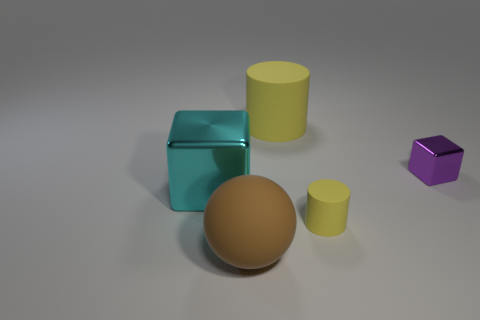Add 4 large yellow matte cylinders. How many objects exist? 9 Subtract all cylinders. How many objects are left? 3 Add 2 blue objects. How many blue objects exist? 2 Subtract 0 cyan cylinders. How many objects are left? 5 Subtract all large cubes. Subtract all small purple shiny objects. How many objects are left? 3 Add 2 small cubes. How many small cubes are left? 3 